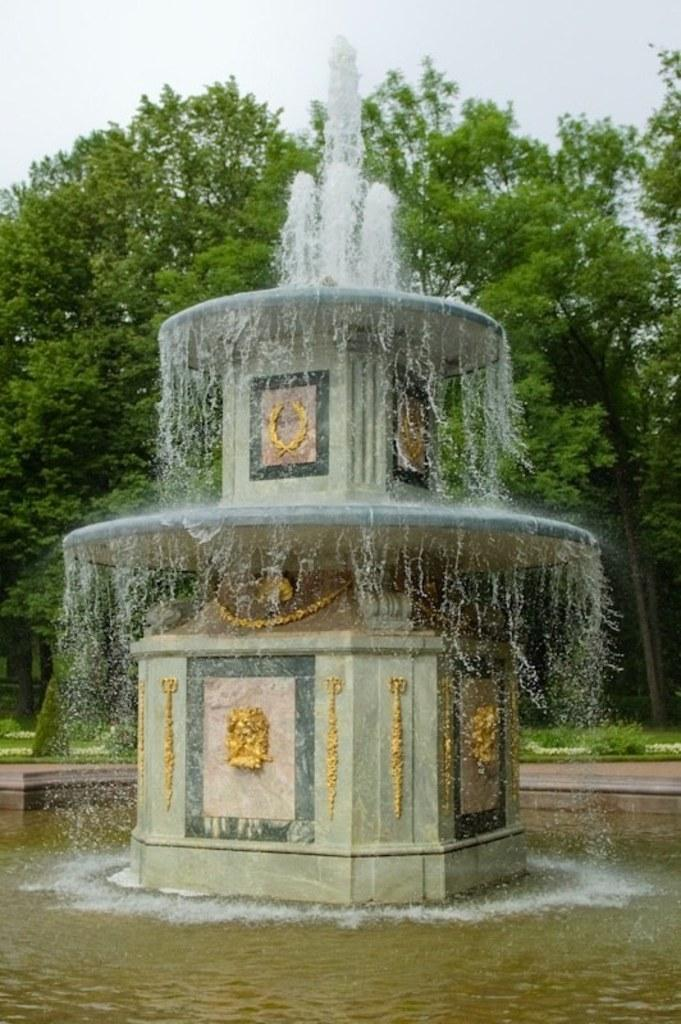What is the main feature in the picture? There is a fountain in the picture. What can be seen at the bottom of the fountain? There is water at the bottom of the fountain. What type of vegetation is visible in the background of the picture? There are trees, plants, and grass in the background of the picture. What is visible at the top of the picture? The sky is visible at the top of the picture. What can be seen in the sky? Clouds are present in the sky. How many kites are being flown by the boys in the picture? There are no kites or boys present in the image. What route does the fountain take to reach the sky? The fountain does not move or take a route; it is a stationary structure in the image. 